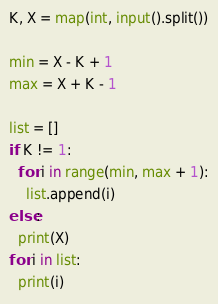Convert code to text. <code><loc_0><loc_0><loc_500><loc_500><_Python_>K, X = map(int, input().split())

min = X - K + 1
max = X + K - 1

list = []
if K != 1:
  for i in range(min, max + 1):
    list.append(i)
else:
  print(X)
for i in list:
  print(i)</code> 